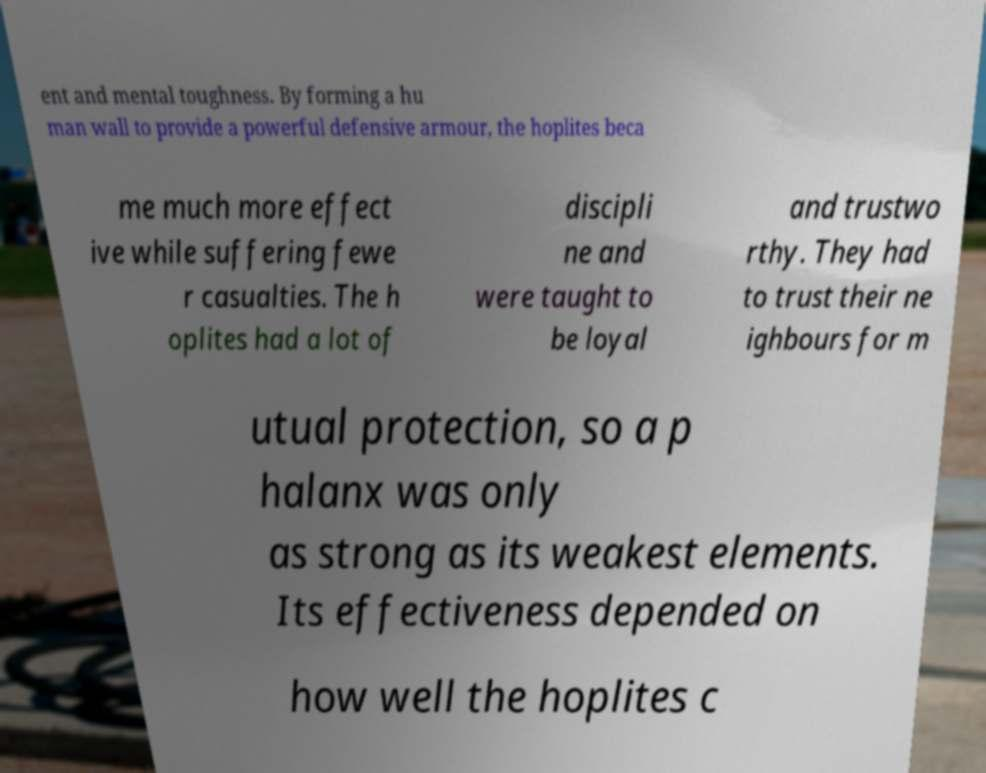Please read and relay the text visible in this image. What does it say? ent and mental toughness. By forming a hu man wall to provide a powerful defensive armour, the hoplites beca me much more effect ive while suffering fewe r casualties. The h oplites had a lot of discipli ne and were taught to be loyal and trustwo rthy. They had to trust their ne ighbours for m utual protection, so a p halanx was only as strong as its weakest elements. Its effectiveness depended on how well the hoplites c 